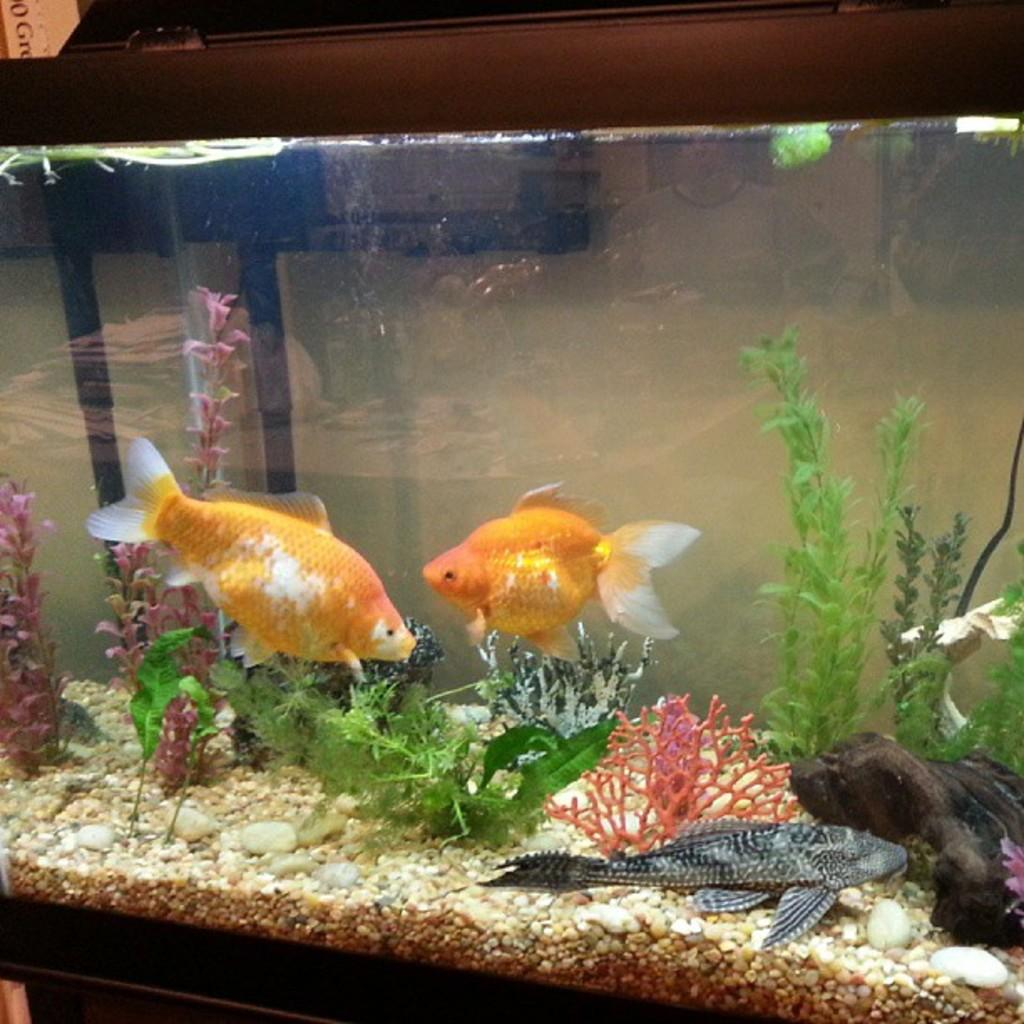What is the main subject in the center of the picture? There is an aquarium in the center of the picture. What can be found inside the aquarium? The aquarium contains fishes, plants, and other objects. What is visible in the background of the picture? There is a wall and other objects visible in the background of the picture. Can you see a glove in the pocket of the goose in the image? There is no goose or glove present in the image; it features an aquarium with fishes, plants, and other objects. 